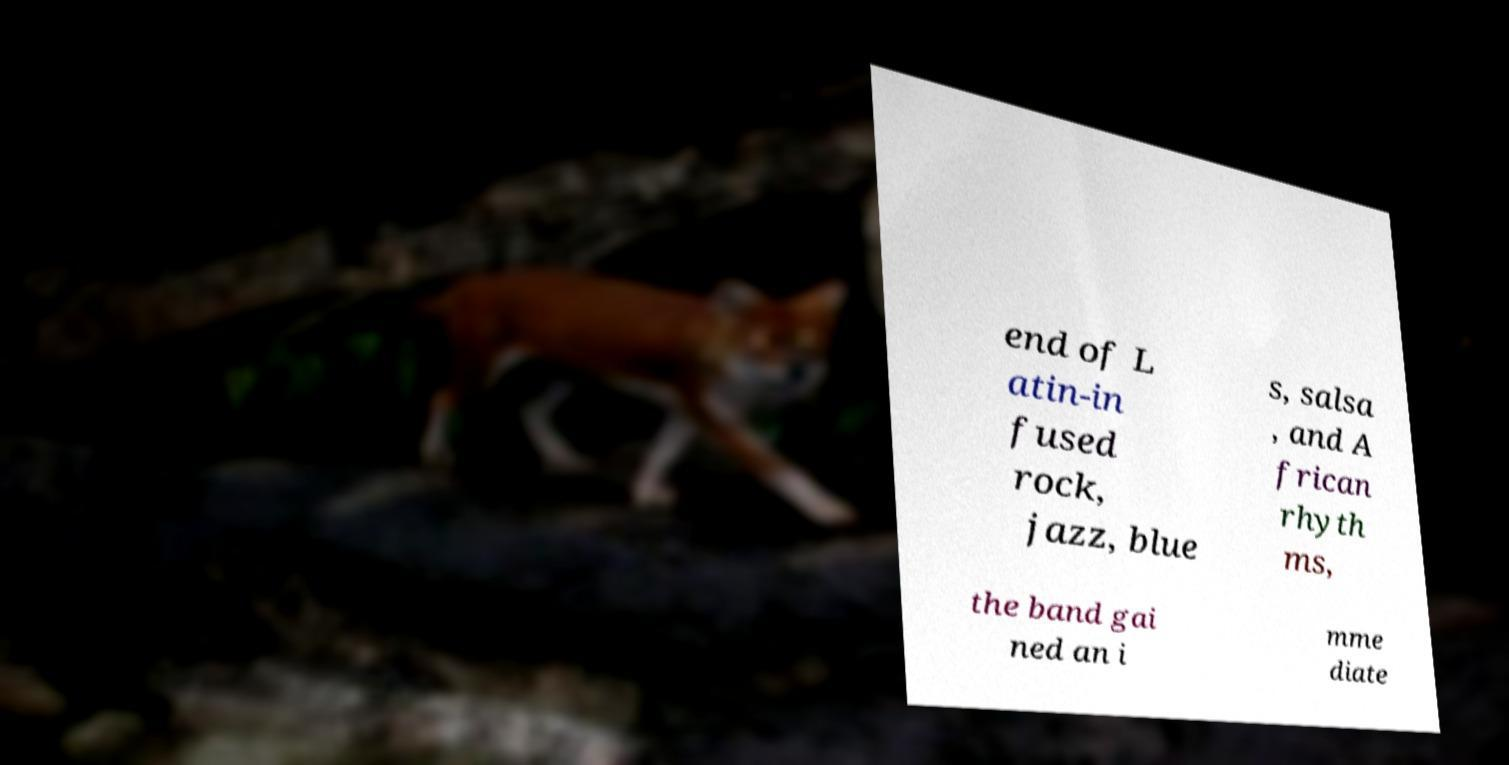Can you read and provide the text displayed in the image?This photo seems to have some interesting text. Can you extract and type it out for me? end of L atin-in fused rock, jazz, blue s, salsa , and A frican rhyth ms, the band gai ned an i mme diate 